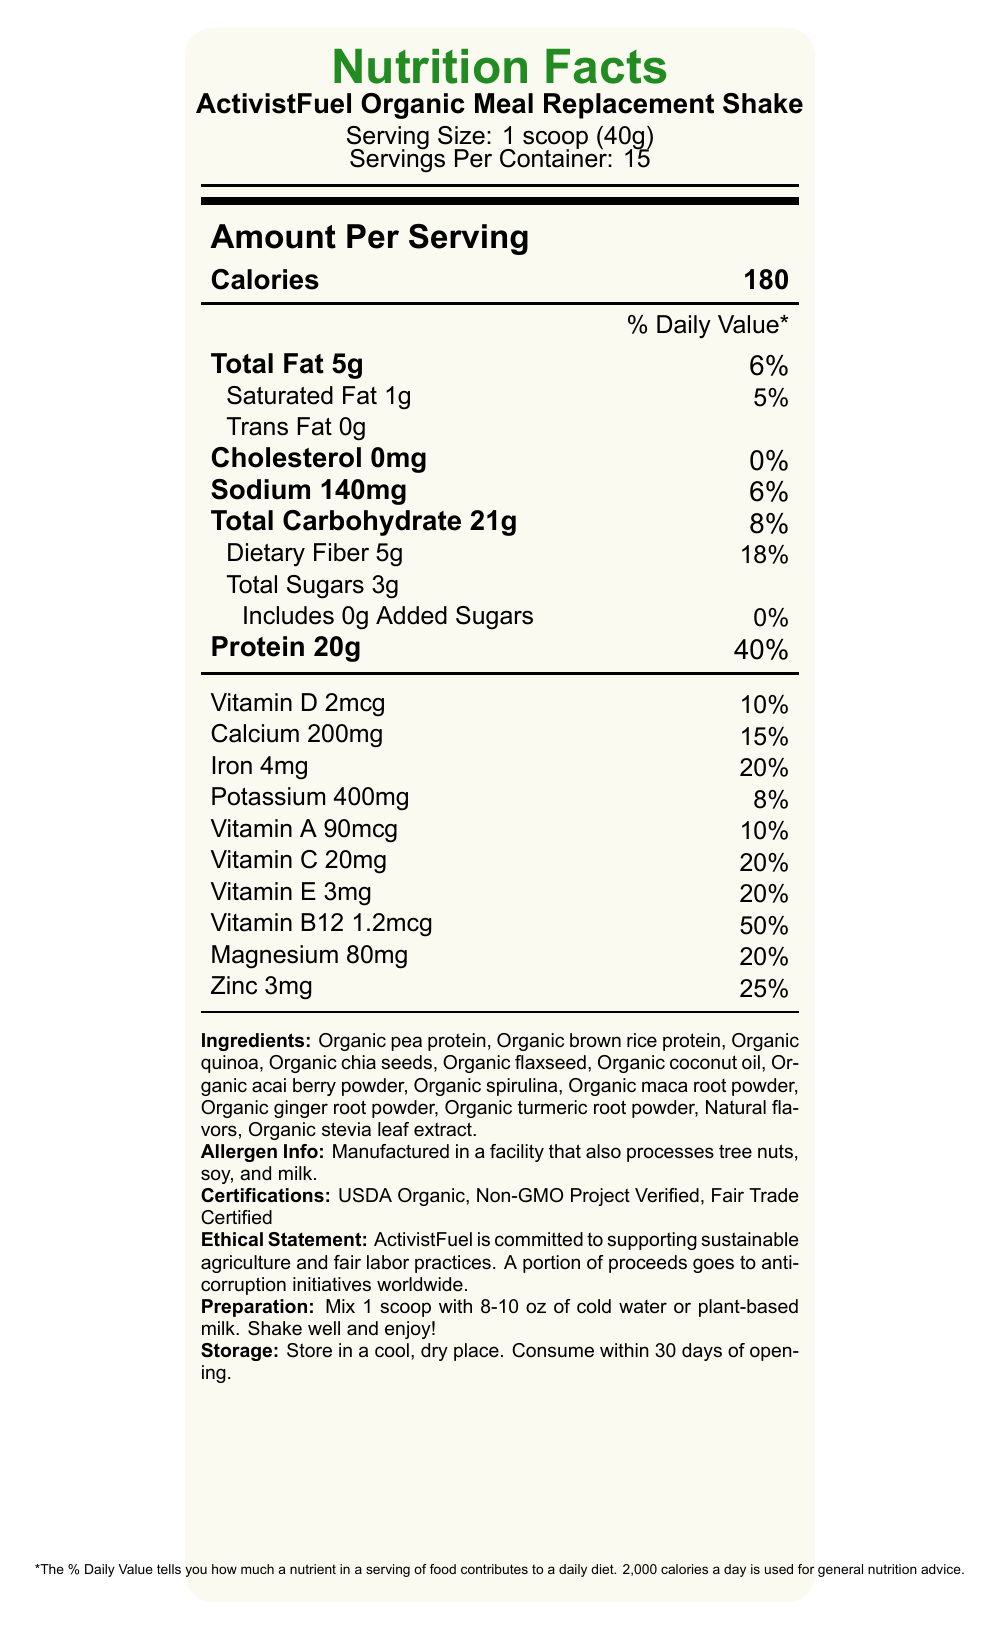what is the serving size of ActivistFuel Organic Meal Replacement Shake? The serving size is clearly mentioned as "1 scoop (40g)" in the document.
Answer: 1 scoop (40g) how many servings are there in one container? The document specifies "Servings Per Container: 15".
Answer: 15 how much protein is in each serving? The nutrition facts state "Protein 20g", indicating the amount per serving.
Answer: 20g what percentage of the daily value is provided by the saturated fat in one serving? The document lists "Saturated Fat 1g" and its daily value percentage as "5%".
Answer: 5% how many calories are there per serving? The document states "Calories 180" under the amount per serving section.
Answer: 180 which of these vitamins has the highest percentage of daily value in one serving: Vitamin D, Vitamin B12, or Vitamin C? A. Vitamin D B. Vitamin B12 C. Vitamin C The daily values for the vitamins are: Vitamin D - 10%, Vitamin B12 - 50%, and Vitamin C - 20%. Thus, Vitamin B12 has the highest percentage.
Answer: B. Vitamin B12 how much sodium is in each serving? The nutrition facts label lists "Sodium 140mg".
Answer: 140mg which ingredient is not included in the ActivistFuel Organic Meal Replacement Shake? A. Organic Brown Rice Protein B. Organic Chia Seeds C. Organic Soy Protein The listed ingredients include "Organic brown rice protein" and "Organic chia seeds", but not "Organic soy protein".
Answer: C. Organic Soy Protein is cholesterol present in the ActivistFuel Organic Meal Replacement Shake? The document indicates "Cholesterol 0mg" and its daily value as "0%," meaning no cholesterol is present.
Answer: No describe the main idea of the document. The document focuses on providing an overview of the nutritional content, ingredients, and ethical commitments associated with ActivistFuel Organic Meal Replacement Shake. It highlights the product's benefits, nutritional value, certifications, and the company's commitment to social causes.
Answer: ActivistFuel Organic Meal Replacement Shake is a healthy, organic product designed for busy activists. It provides detailed nutritional information, contains numerous vitamins and minerals, and is made from organic ingredients. The product is also ethically produced with certifications such as USDA Organic, Non-GMO Project Verified, and Fair Trade Certified. It supports anti-corruption initiatives and sustainable agriculture. what is the primary ingredient in the shake? The first ingredient listed under "Ingredients" is "Organic pea protein."
Answer: Organic Pea Protein what is the total amount of sugars, including added sugars, in one serving? The document lists "Total Sugars 3g" and "Includes 0g Added Sugars," indicating the total sugar content is 3 grams.
Answer: 3g which certification is not listed on the document? A. USDA Organic B. Non-GMO Project Verified C. Certified Vegan The document lists "USDA Organic," "Non-GMO Project Verified," and "Fair Trade Certified," but not "Certified Vegan."
Answer: C. Certified Vegan can you determine the exact date the product was manufactured? The document does not provide any details about the manufacturing date of the product.
Answer: Not enough information how should the product be prepared? The preparation instructions in the document state to "Mix 1 scoop with 8-10 oz of cold water or plant-based milk. Shake well and enjoy!"
Answer: Mix 1 scoop with 8-10 oz of cold water or plant-based milk. Shake well and enjoy! what percent of daily value of iron does one serving provide? The document states "Iron 4mg" and lists its daily value percentage as "20%."
Answer: 20% are there any allergens present in the manufacturing facility? The allergen information mentions, "Manufactured in a facility that also processes tree nuts, soy, and milk," indicating potential allergen exposure.
Answer: Yes what is the ethical commitment mentioned in the document? The ethical statement in the document details the company's commitment to sustainable practices and anti-corruption initiatives.
Answer: ActivistFuel is committed to supporting sustainable agriculture and fair labor practices. A portion of proceeds goes to anti-corruption initiatives worldwide. 